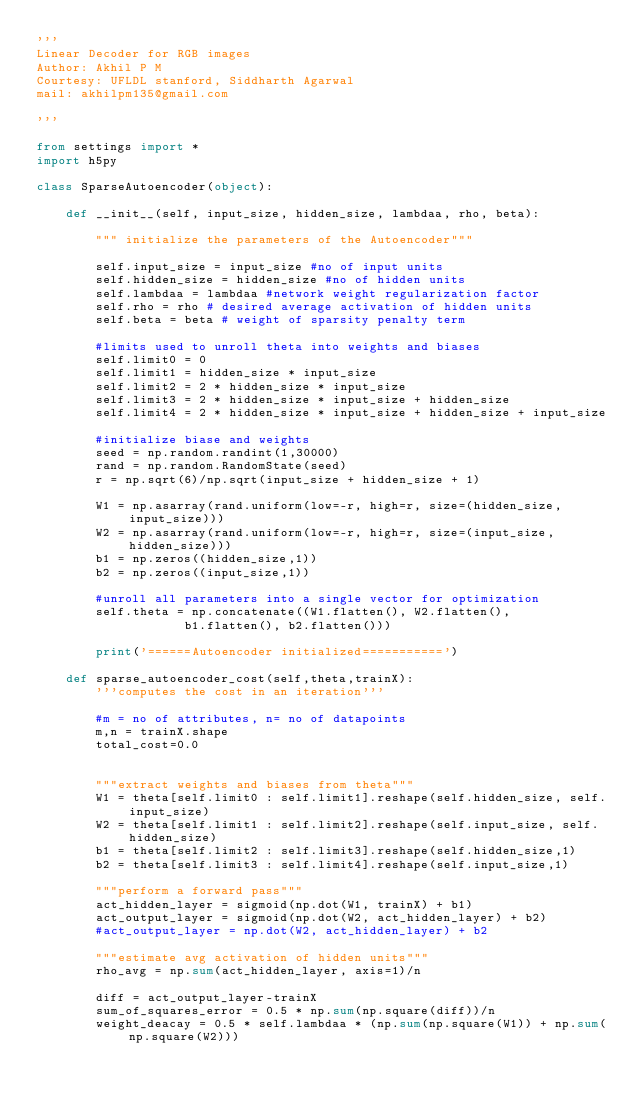<code> <loc_0><loc_0><loc_500><loc_500><_Python_>'''
Linear Decoder for RGB images
Author: Akhil P M
Courtesy: UFLDL stanford, Siddharth Agarwal
mail: akhilpm135@gmail.com

'''

from settings import *
import h5py

class SparseAutoencoder(object):

	def __init__(self, input_size, hidden_size, lambdaa, rho, beta):

		""" initialize the parameters of the Autoencoder"""

		self.input_size = input_size #no of input units
		self.hidden_size = hidden_size #no of hidden units
		self.lambdaa = lambdaa #network weight regularization factor
		self.rho = rho # desired average activation of hidden units
		self.beta = beta # weight of sparsity penalty term

		#limits used to unroll theta into weights and biases
		self.limit0 = 0
		self.limit1 = hidden_size * input_size
		self.limit2 = 2 * hidden_size * input_size
		self.limit3 = 2 * hidden_size * input_size + hidden_size
		self.limit4 = 2 * hidden_size * input_size + hidden_size + input_size

		#initialize biase and weights
		seed = np.random.randint(1,30000)
		rand = np.random.RandomState(seed)
		r = np.sqrt(6)/np.sqrt(input_size + hidden_size + 1)

		W1 = np.asarray(rand.uniform(low=-r, high=r, size=(hidden_size, input_size)))
		W2 = np.asarray(rand.uniform(low=-r, high=r, size=(input_size, hidden_size)))
		b1 = np.zeros((hidden_size,1))
		b2 = np.zeros((input_size,1))

		#unroll all parameters into a single vector for optimization
		self.theta = np.concatenate((W1.flatten(), W2.flatten(),
					b1.flatten(), b2.flatten()))

		print('======Autoencoder initialized===========')

	def sparse_autoencoder_cost(self,theta,trainX):
		'''computes the cost in an iteration'''

		#m = no of attributes, n= no of datapoints
		m,n = trainX.shape
		total_cost=0.0


		"""extract weights and biases from theta"""
		W1 = theta[self.limit0 : self.limit1].reshape(self.hidden_size, self.input_size)
		W2 = theta[self.limit1 : self.limit2].reshape(self.input_size, self.hidden_size)
		b1 = theta[self.limit2 : self.limit3].reshape(self.hidden_size,1)
		b2 = theta[self.limit3 : self.limit4].reshape(self.input_size,1)

		"""perform a forward pass"""
		act_hidden_layer = sigmoid(np.dot(W1, trainX) + b1)
		act_output_layer = sigmoid(np.dot(W2, act_hidden_layer) + b2)
		#act_output_layer = np.dot(W2, act_hidden_layer) + b2		

		"""estimate avg activation of hidden units"""
		rho_avg = np.sum(act_hidden_layer, axis=1)/n

		diff = act_output_layer-trainX
		sum_of_squares_error = 0.5 * np.sum(np.square(diff))/n
		weight_deacay = 0.5 * self.lambdaa * (np.sum(np.square(W1)) + np.sum(np.square(W2)))</code> 